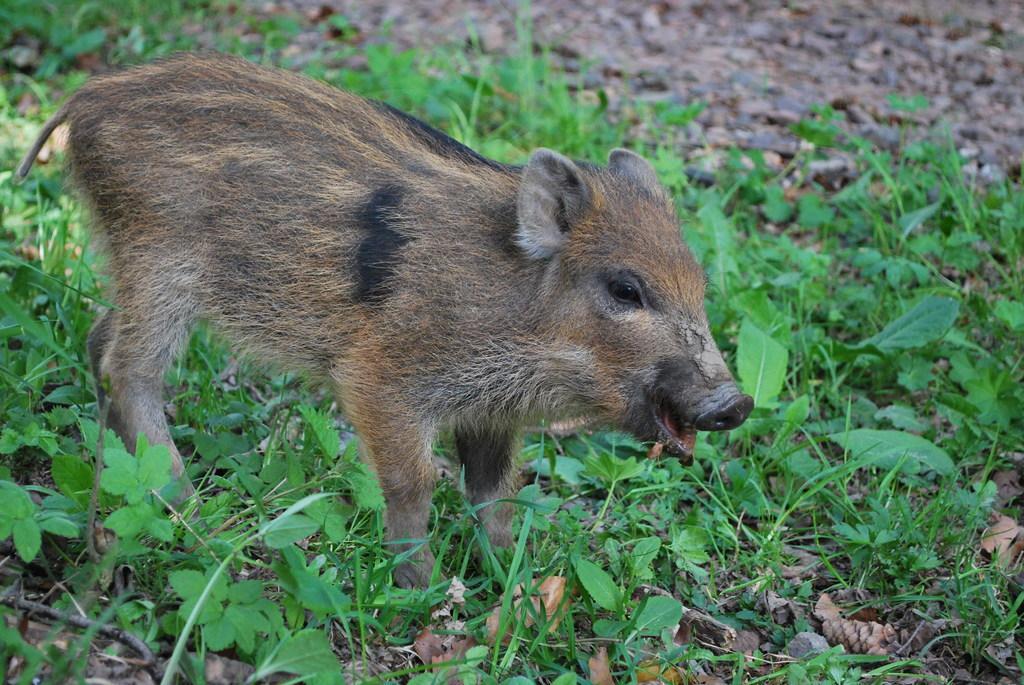In one or two sentences, can you explain what this image depicts? In this image we can see an animal on the ground. On the right side of the image we can see some plants and the grass. 